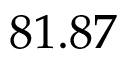<formula> <loc_0><loc_0><loc_500><loc_500>8 1 . 8 7</formula> 